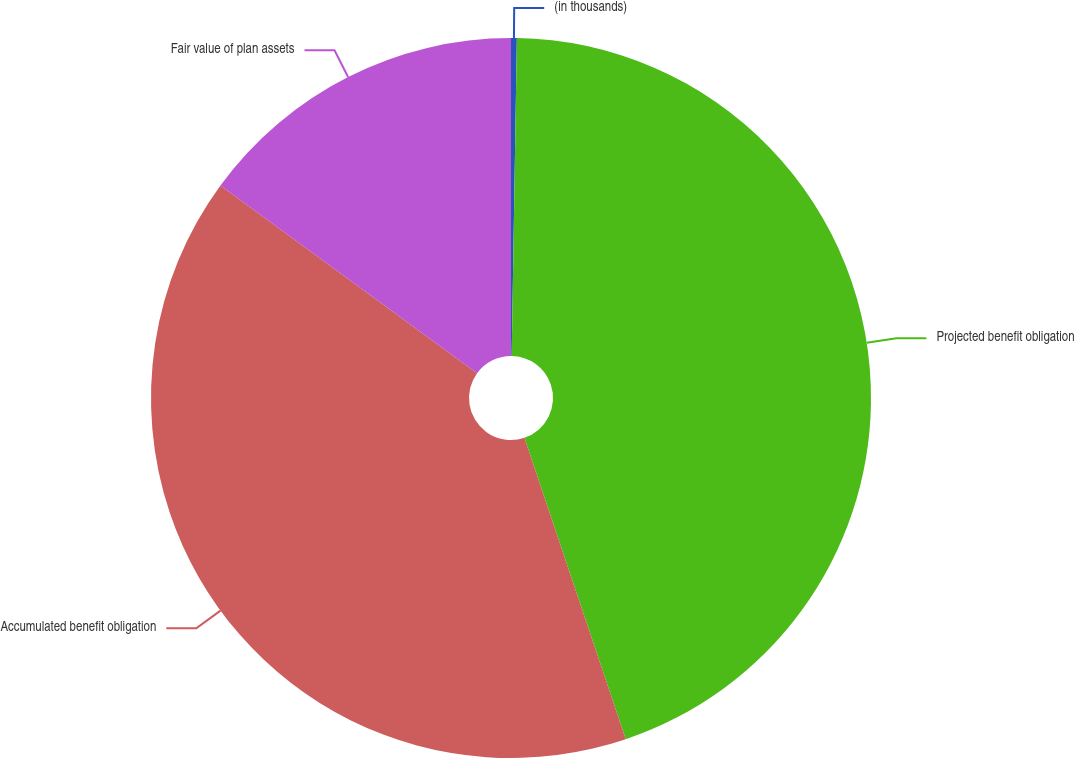Convert chart. <chart><loc_0><loc_0><loc_500><loc_500><pie_chart><fcel>(in thousands)<fcel>Projected benefit obligation<fcel>Accumulated benefit obligation<fcel>Fair value of plan assets<nl><fcel>0.26%<fcel>44.58%<fcel>40.22%<fcel>14.95%<nl></chart> 